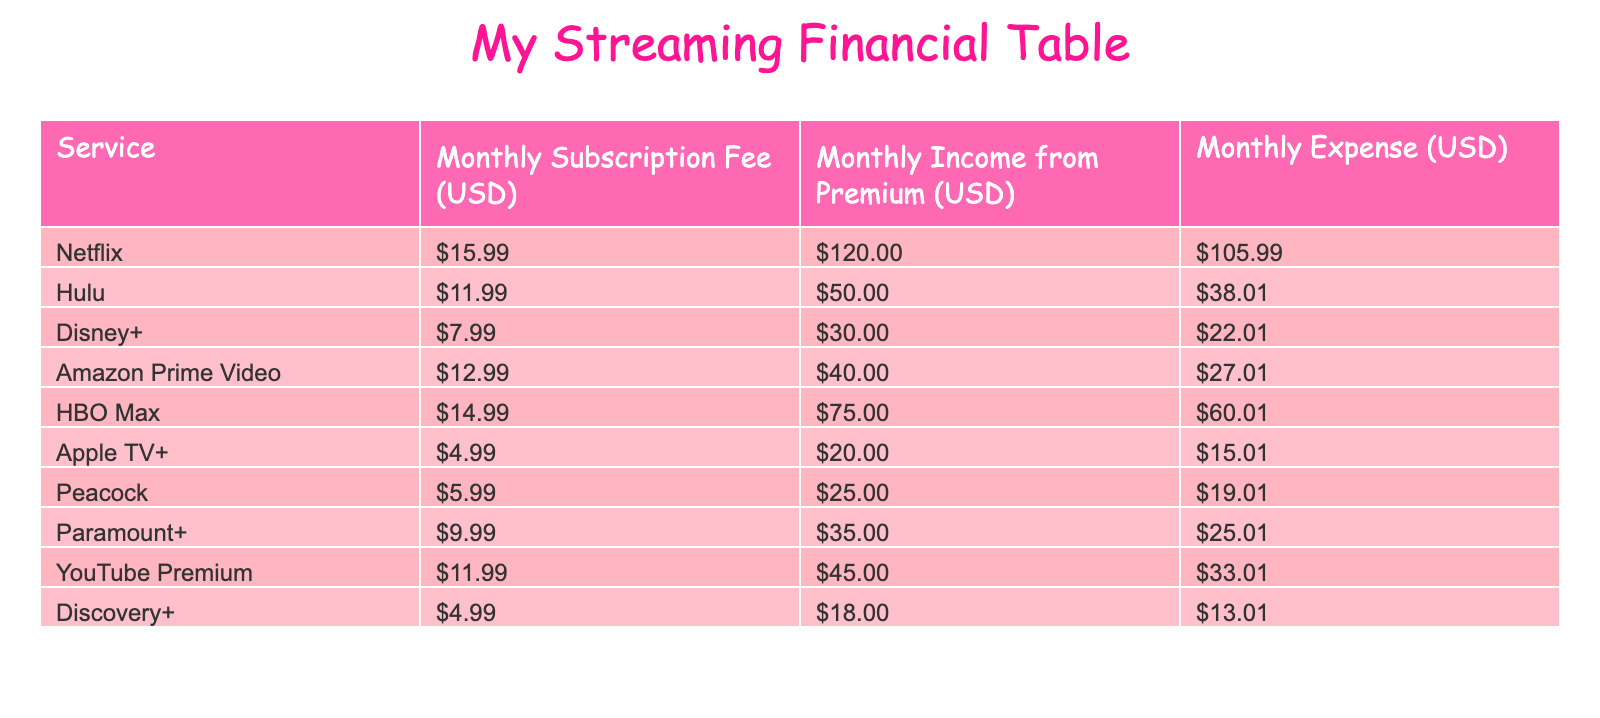What is the monthly subscription fee for Netflix? The table shows that the monthly subscription fee for Netflix is listed under the column "Monthly Subscription Fee (USD)." By looking at the row for Netflix, the fee is clearly stated as 15.99.
Answer: 15.99 What is the total monthly income from all streaming services? To find the total monthly income, I need to sum the "Monthly Income from Premium (USD)" values from all services. Adding them together: 120 + 50 + 30 + 40 + 75 + 20 + 25 + 35 + 45 + 18 equals 453.
Answer: 453 Is the monthly expense for Hulu less than the monthly subscription fee? By comparing the values in the table, the monthly expense for Hulu is listed as 38.01 and the subscription fee is 11.99. Since 38.01 is greater than 11.99, this statement is false.
Answer: No Which streaming service has the highest difference between monthly income and monthly expense? I need to calculate the difference for each service by subtracting "Monthly Expense (USD)" from "Monthly Income from Premium (USD)." Checking the differences: Netflix (120 - 105.99 = 14.01), Hulu (50 - 38.01 = 11.99), Disney+ (30 - 22.01 = 7.99), ... The highest difference is for Netflix with 14.01.
Answer: Netflix What is the average monthly expense across all services? To find the average, I sum up all the monthly expenses and then divide by the number of services. Adding the expenses yields (105.99 + 38.01 + 22.01 + 27.01 + 60.01 + 15.01 + 19.01 + 25.01 + 33.01 + 13.01 = 353.05). There are 10 services, so the average expense is 353.05 / 10 = 35.305.
Answer: 35.31 